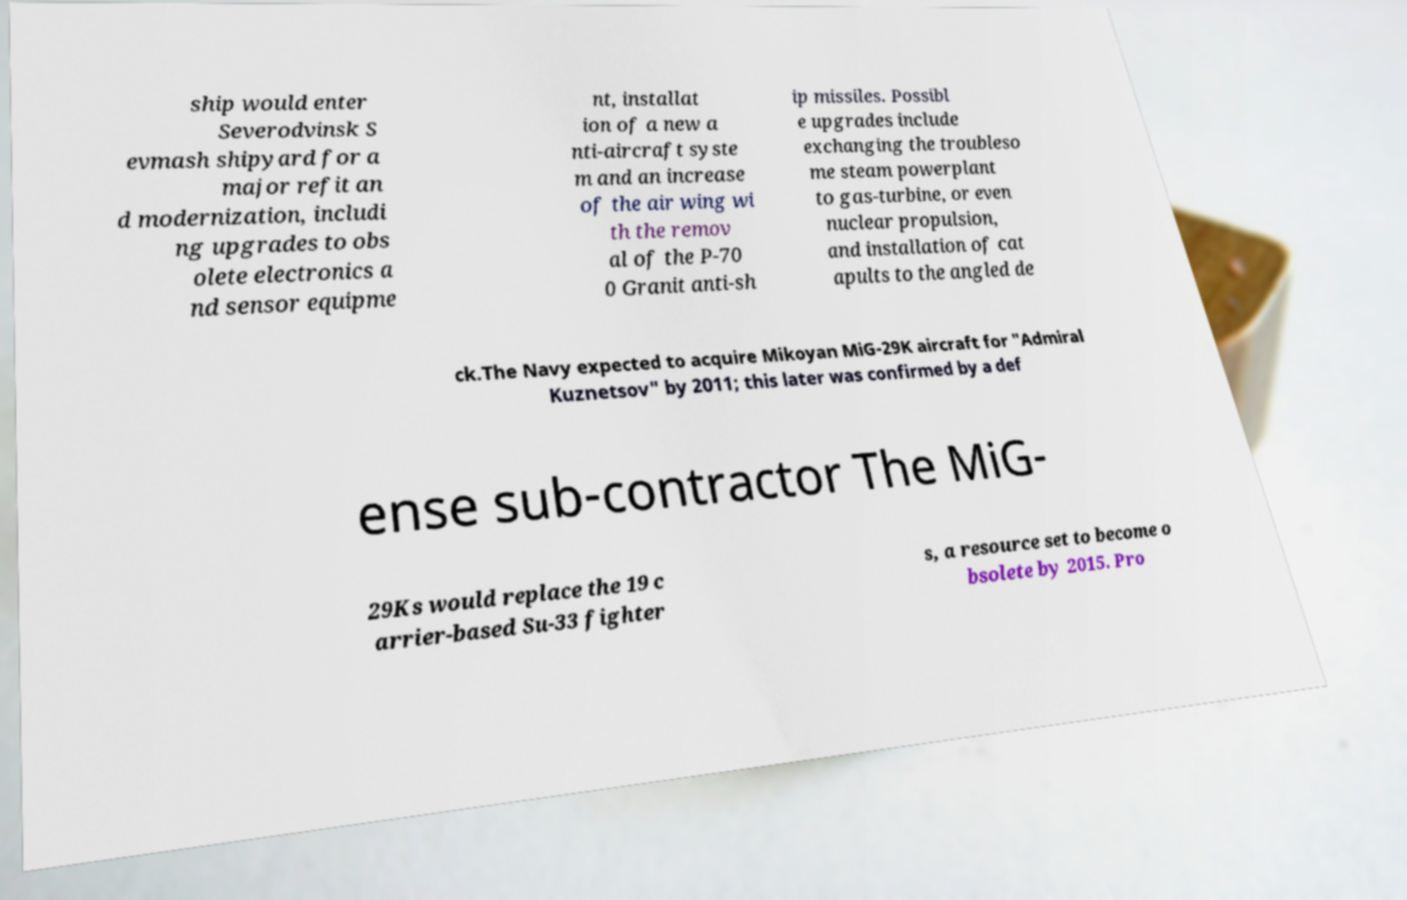Please identify and transcribe the text found in this image. ship would enter Severodvinsk S evmash shipyard for a major refit an d modernization, includi ng upgrades to obs olete electronics a nd sensor equipme nt, installat ion of a new a nti-aircraft syste m and an increase of the air wing wi th the remov al of the P-70 0 Granit anti-sh ip missiles. Possibl e upgrades include exchanging the troubleso me steam powerplant to gas-turbine, or even nuclear propulsion, and installation of cat apults to the angled de ck.The Navy expected to acquire Mikoyan MiG-29K aircraft for "Admiral Kuznetsov" by 2011; this later was confirmed by a def ense sub-contractor The MiG- 29Ks would replace the 19 c arrier-based Su-33 fighter s, a resource set to become o bsolete by 2015. Pro 